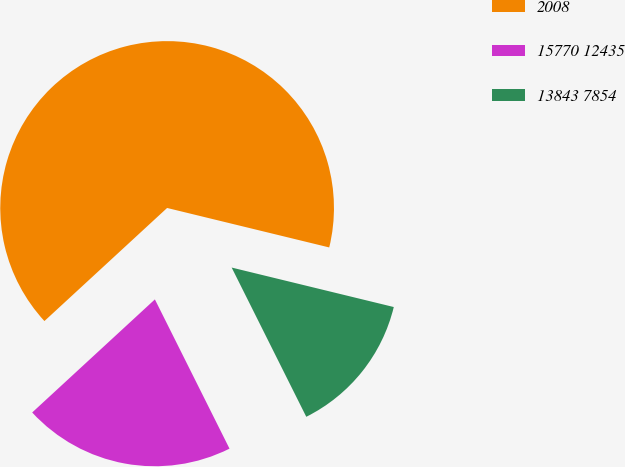Convert chart. <chart><loc_0><loc_0><loc_500><loc_500><pie_chart><fcel>2008<fcel>15770 12435<fcel>13843 7854<nl><fcel>65.66%<fcel>20.53%<fcel>13.82%<nl></chart> 